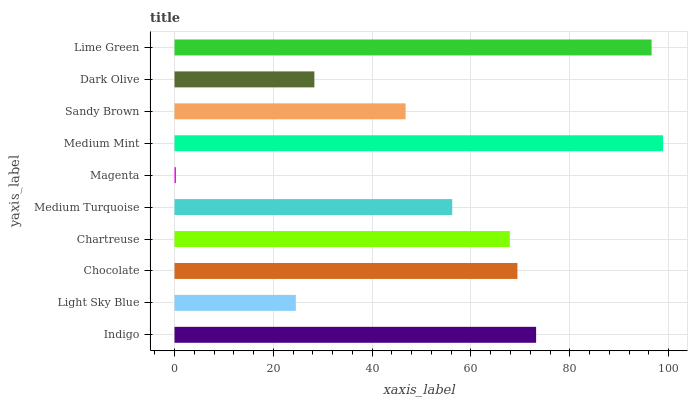Is Magenta the minimum?
Answer yes or no. Yes. Is Medium Mint the maximum?
Answer yes or no. Yes. Is Light Sky Blue the minimum?
Answer yes or no. No. Is Light Sky Blue the maximum?
Answer yes or no. No. Is Indigo greater than Light Sky Blue?
Answer yes or no. Yes. Is Light Sky Blue less than Indigo?
Answer yes or no. Yes. Is Light Sky Blue greater than Indigo?
Answer yes or no. No. Is Indigo less than Light Sky Blue?
Answer yes or no. No. Is Chartreuse the high median?
Answer yes or no. Yes. Is Medium Turquoise the low median?
Answer yes or no. Yes. Is Medium Mint the high median?
Answer yes or no. No. Is Light Sky Blue the low median?
Answer yes or no. No. 